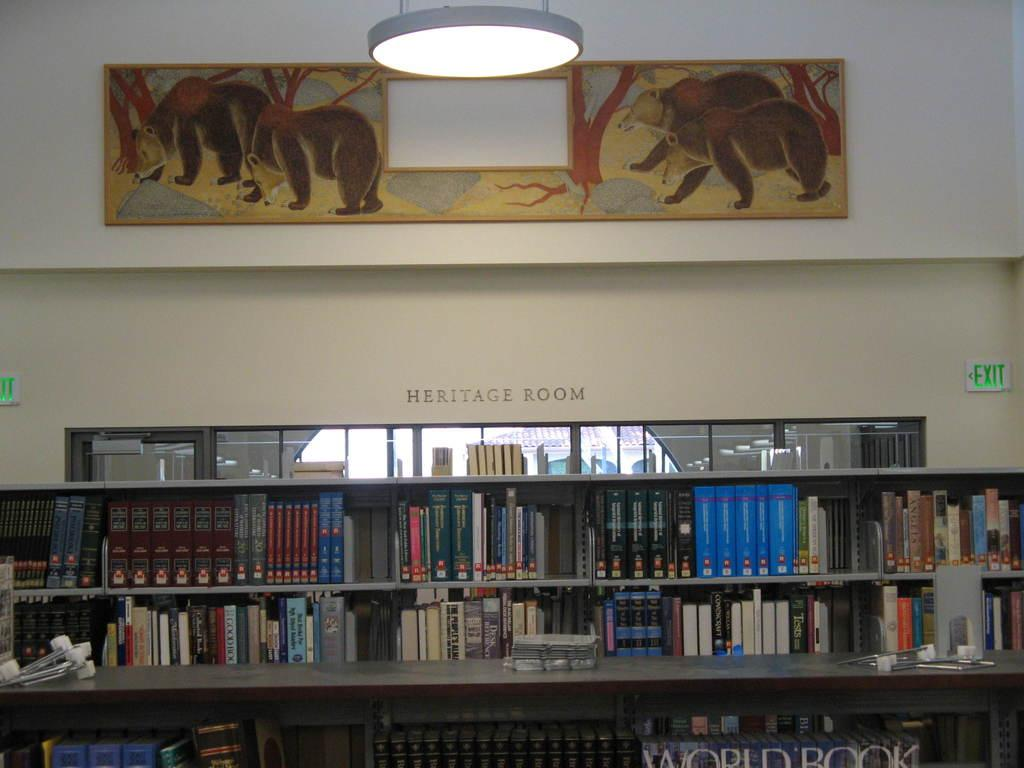<image>
Present a compact description of the photo's key features. The Heritage Room with grey bookshelves and a bear mural on the wall 